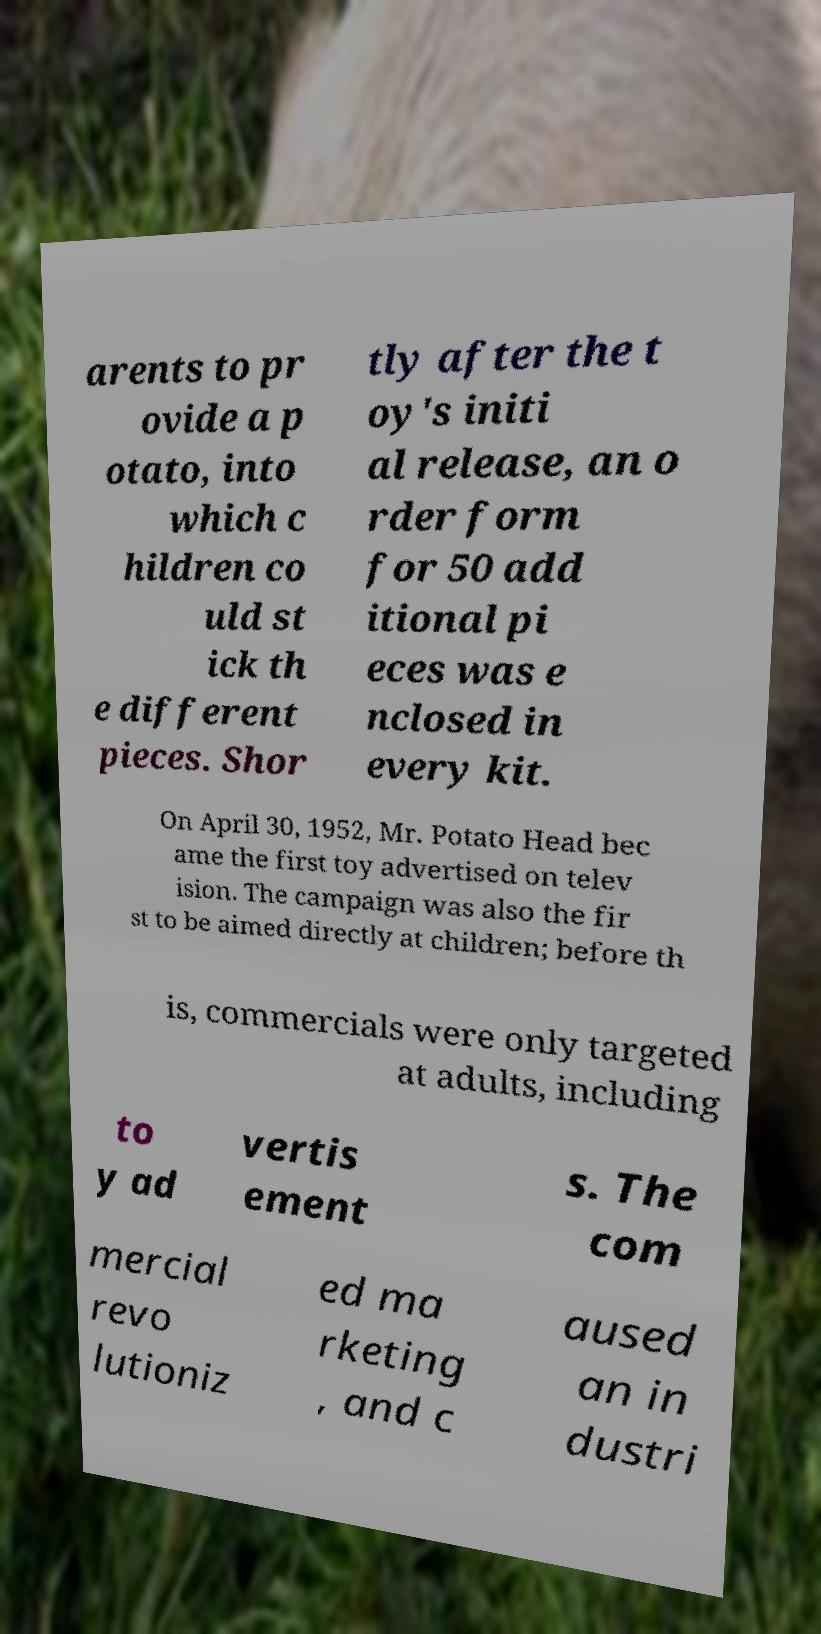Please identify and transcribe the text found in this image. arents to pr ovide a p otato, into which c hildren co uld st ick th e different pieces. Shor tly after the t oy's initi al release, an o rder form for 50 add itional pi eces was e nclosed in every kit. On April 30, 1952, Mr. Potato Head bec ame the first toy advertised on telev ision. The campaign was also the fir st to be aimed directly at children; before th is, commercials were only targeted at adults, including to y ad vertis ement s. The com mercial revo lutioniz ed ma rketing , and c aused an in dustri 